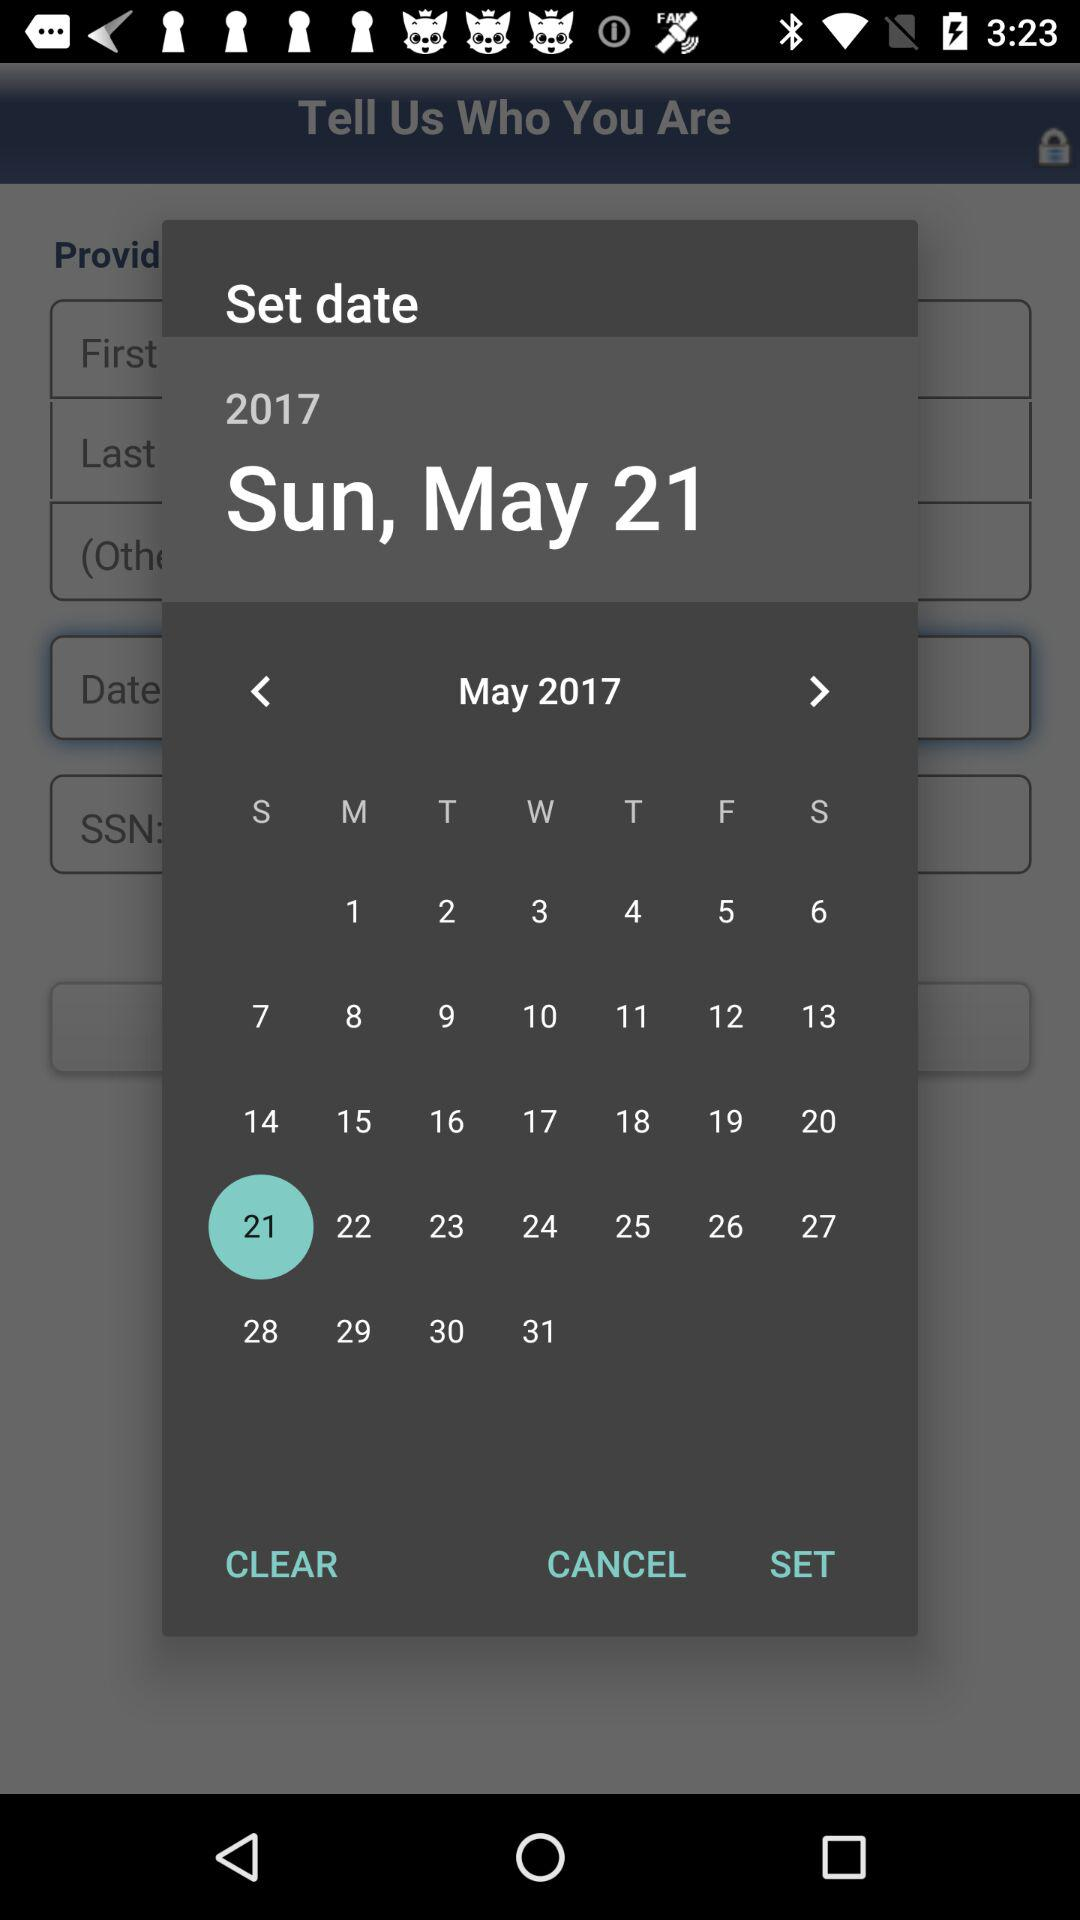Which date is selected? The selected date is Sunday, May 21, 2017. 